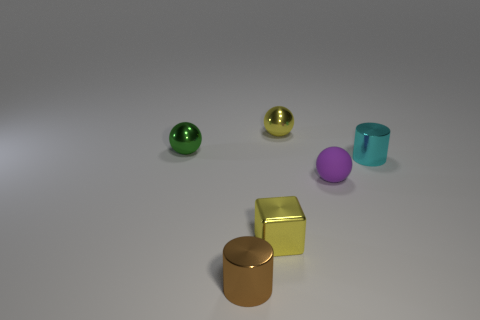Are there the same number of tiny metal balls that are on the left side of the tiny metal block and small cyan objects on the right side of the rubber ball?
Ensure brevity in your answer.  Yes. There is a tiny cylinder that is to the left of the cyan shiny cylinder; what is its material?
Provide a short and direct response. Metal. Is the number of cubes less than the number of tiny green shiny cylinders?
Provide a short and direct response. No. The small metallic thing that is both behind the brown shiny object and in front of the tiny cyan metal thing has what shape?
Give a very brief answer. Cube. What number of large purple cubes are there?
Provide a short and direct response. 0. There is a tiny ball in front of the tiny metal cylinder that is behind the metallic cylinder that is in front of the rubber thing; what is it made of?
Make the answer very short. Rubber. How many small cyan shiny cylinders are in front of the cylinder left of the purple matte ball?
Keep it short and to the point. 0. What color is the other small object that is the same shape as the cyan metal object?
Provide a succinct answer. Brown. Is the green ball made of the same material as the brown cylinder?
Offer a terse response. Yes. How many cubes are either brown objects or cyan metallic things?
Offer a terse response. 0. 